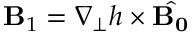Convert formula to latex. <formula><loc_0><loc_0><loc_500><loc_500>{ B } _ { 1 } = \nabla _ { \perp } h \times { \hat { B _ { 0 } } }</formula> 